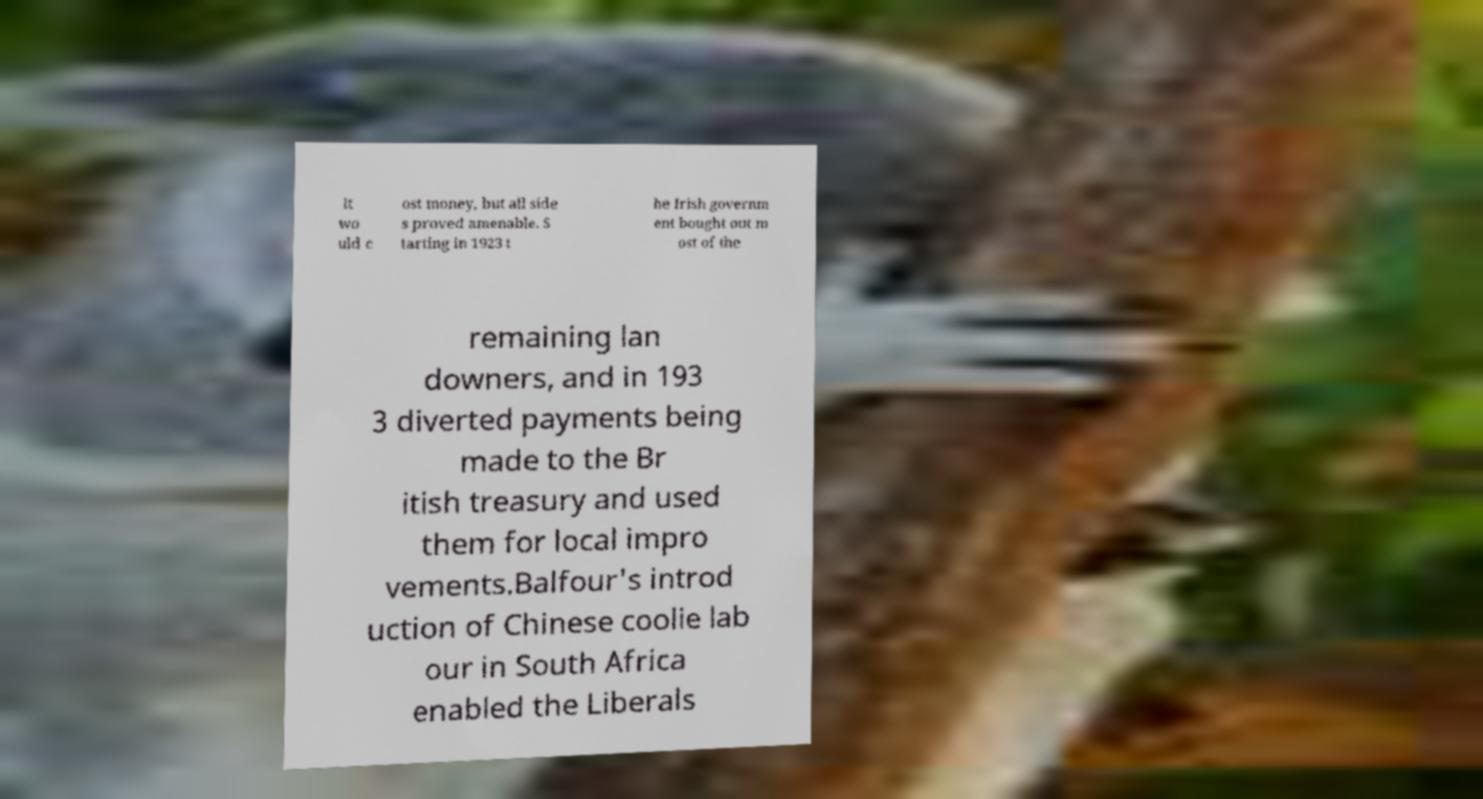Can you read and provide the text displayed in the image?This photo seems to have some interesting text. Can you extract and type it out for me? It wo uld c ost money, but all side s proved amenable. S tarting in 1923 t he Irish governm ent bought out m ost of the remaining lan downers, and in 193 3 diverted payments being made to the Br itish treasury and used them for local impro vements.Balfour's introd uction of Chinese coolie lab our in South Africa enabled the Liberals 